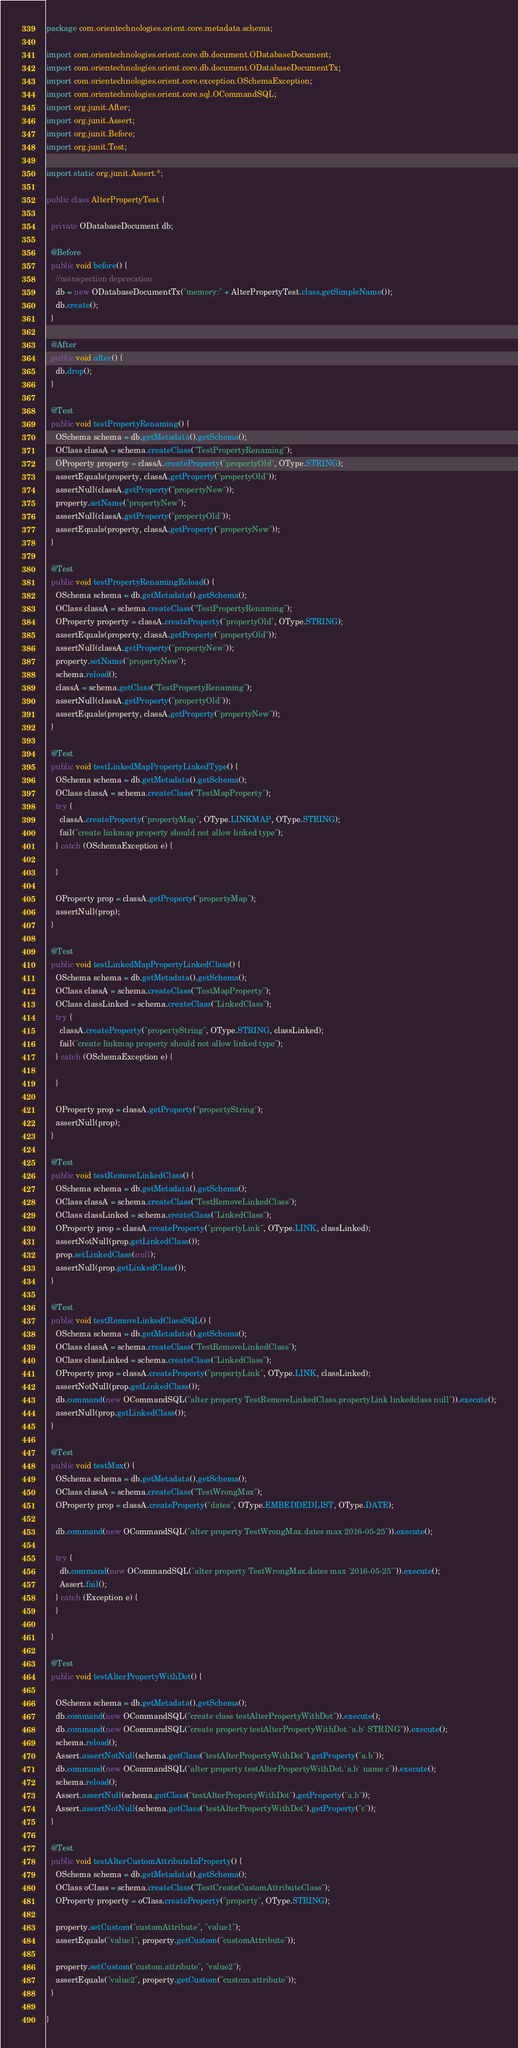Convert code to text. <code><loc_0><loc_0><loc_500><loc_500><_Java_>package com.orientechnologies.orient.core.metadata.schema;

import com.orientechnologies.orient.core.db.document.ODatabaseDocument;
import com.orientechnologies.orient.core.db.document.ODatabaseDocumentTx;
import com.orientechnologies.orient.core.exception.OSchemaException;
import com.orientechnologies.orient.core.sql.OCommandSQL;
import org.junit.After;
import org.junit.Assert;
import org.junit.Before;
import org.junit.Test;

import static org.junit.Assert.*;

public class AlterPropertyTest {

  private ODatabaseDocument db;

  @Before
  public void before() {
    //noinspection deprecation
    db = new ODatabaseDocumentTx("memory:" + AlterPropertyTest.class.getSimpleName());
    db.create();
  }

  @After
  public void after() {
    db.drop();
  }

  @Test
  public void testPropertyRenaming() {
    OSchema schema = db.getMetadata().getSchema();
    OClass classA = schema.createClass("TestPropertyRenaming");
    OProperty property = classA.createProperty("propertyOld", OType.STRING);
    assertEquals(property, classA.getProperty("propertyOld"));
    assertNull(classA.getProperty("propertyNew"));
    property.setName("propertyNew");
    assertNull(classA.getProperty("propertyOld"));
    assertEquals(property, classA.getProperty("propertyNew"));
  }

  @Test
  public void testPropertyRenamingReload() {
    OSchema schema = db.getMetadata().getSchema();
    OClass classA = schema.createClass("TestPropertyRenaming");
    OProperty property = classA.createProperty("propertyOld", OType.STRING);
    assertEquals(property, classA.getProperty("propertyOld"));
    assertNull(classA.getProperty("propertyNew"));
    property.setName("propertyNew");
    schema.reload();
    classA = schema.getClass("TestPropertyRenaming");
    assertNull(classA.getProperty("propertyOld"));
    assertEquals(property, classA.getProperty("propertyNew"));
  }

  @Test
  public void testLinkedMapPropertyLinkedType() {
    OSchema schema = db.getMetadata().getSchema();
    OClass classA = schema.createClass("TestMapProperty");
    try {
      classA.createProperty("propertyMap", OType.LINKMAP, OType.STRING);
      fail("create linkmap property should not allow linked type");
    } catch (OSchemaException e) {

    }

    OProperty prop = classA.getProperty("propertyMap");
    assertNull(prop);
  }

  @Test
  public void testLinkedMapPropertyLinkedClass() {
    OSchema schema = db.getMetadata().getSchema();
    OClass classA = schema.createClass("TestMapProperty");
    OClass classLinked = schema.createClass("LinkedClass");
    try {
      classA.createProperty("propertyString", OType.STRING, classLinked);
      fail("create linkmap property should not allow linked type");
    } catch (OSchemaException e) {

    }

    OProperty prop = classA.getProperty("propertyString");
    assertNull(prop);
  }

  @Test
  public void testRemoveLinkedClass() {
    OSchema schema = db.getMetadata().getSchema();
    OClass classA = schema.createClass("TestRemoveLinkedClass");
    OClass classLinked = schema.createClass("LinkedClass");
    OProperty prop = classA.createProperty("propertyLink", OType.LINK, classLinked);
    assertNotNull(prop.getLinkedClass());
    prop.setLinkedClass(null);
    assertNull(prop.getLinkedClass());
  }

  @Test
  public void testRemoveLinkedClassSQL() {
    OSchema schema = db.getMetadata().getSchema();
    OClass classA = schema.createClass("TestRemoveLinkedClass");
    OClass classLinked = schema.createClass("LinkedClass");
    OProperty prop = classA.createProperty("propertyLink", OType.LINK, classLinked);
    assertNotNull(prop.getLinkedClass());
    db.command(new OCommandSQL("alter property TestRemoveLinkedClass.propertyLink linkedclass null")).execute();
    assertNull(prop.getLinkedClass());
  }

  @Test
  public void testMax() {
    OSchema schema = db.getMetadata().getSchema();
    OClass classA = schema.createClass("TestWrongMax");
    OProperty prop = classA.createProperty("dates", OType.EMBEDDEDLIST, OType.DATE);

    db.command(new OCommandSQL("alter property TestWrongMax.dates max 2016-05-25")).execute();

    try {
      db.command(new OCommandSQL("alter property TestWrongMax.dates max '2016-05-25'")).execute();
      Assert.fail();
    } catch (Exception e) {
    }

  }

  @Test
  public void testAlterPropertyWithDot() {

    OSchema schema = db.getMetadata().getSchema();
    db.command(new OCommandSQL("create class testAlterPropertyWithDot")).execute();
    db.command(new OCommandSQL("create property testAlterPropertyWithDot.`a.b` STRING")).execute();
    schema.reload();
    Assert.assertNotNull(schema.getClass("testAlterPropertyWithDot").getProperty("a.b"));
    db.command(new OCommandSQL("alter property testAlterPropertyWithDot.`a.b` name c")).execute();
    schema.reload();
    Assert.assertNull(schema.getClass("testAlterPropertyWithDot").getProperty("a.b"));
    Assert.assertNotNull(schema.getClass("testAlterPropertyWithDot").getProperty("c"));
  }

  @Test
  public void testAlterCustomAttributeInProperty() {
    OSchema schema = db.getMetadata().getSchema();
    OClass oClass = schema.createClass("TestCreateCustomAttributeClass");
    OProperty property = oClass.createProperty("property", OType.STRING);

    property.setCustom("customAttribute", "value1");
    assertEquals("value1", property.getCustom("customAttribute"));

    property.setCustom("custom.attribute", "value2");
    assertEquals("value2", property.getCustom("custom.attribute"));
  }

}
</code> 